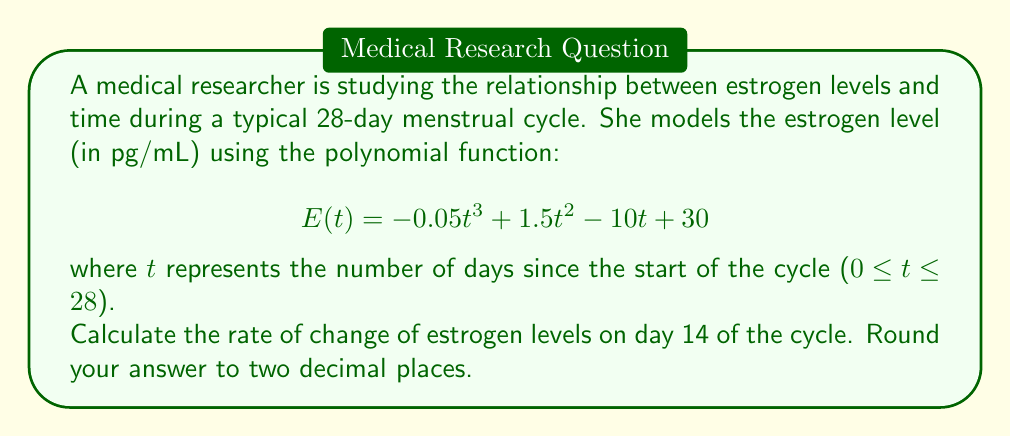Teach me how to tackle this problem. To find the rate of change of estrogen levels on day 14, we need to calculate the derivative of the given function $E(t)$ and then evaluate it at $t = 14$.

Step 1: Find the derivative of $E(t)$
The derivative of $E(t)$ with respect to $t$ is:

$$E'(t) = -0.15t^2 + 3t - 10$$

This represents the rate of change of estrogen levels at any given day $t$.

Step 2: Evaluate $E'(t)$ at $t = 14$
Substitute $t = 14$ into the derivative function:

$$E'(14) = -0.15(14)^2 + 3(14) - 10$$

Step 3: Calculate the result
$$\begin{align*}
E'(14) &= -0.15(196) + 42 - 10 \\
&= -29.4 + 42 - 10 \\
&= 2.6
\end{align*}$$

Step 4: Round to two decimal places
The result is already in two decimal places, so no further rounding is needed.
Answer: 2.60 pg/mL per day 